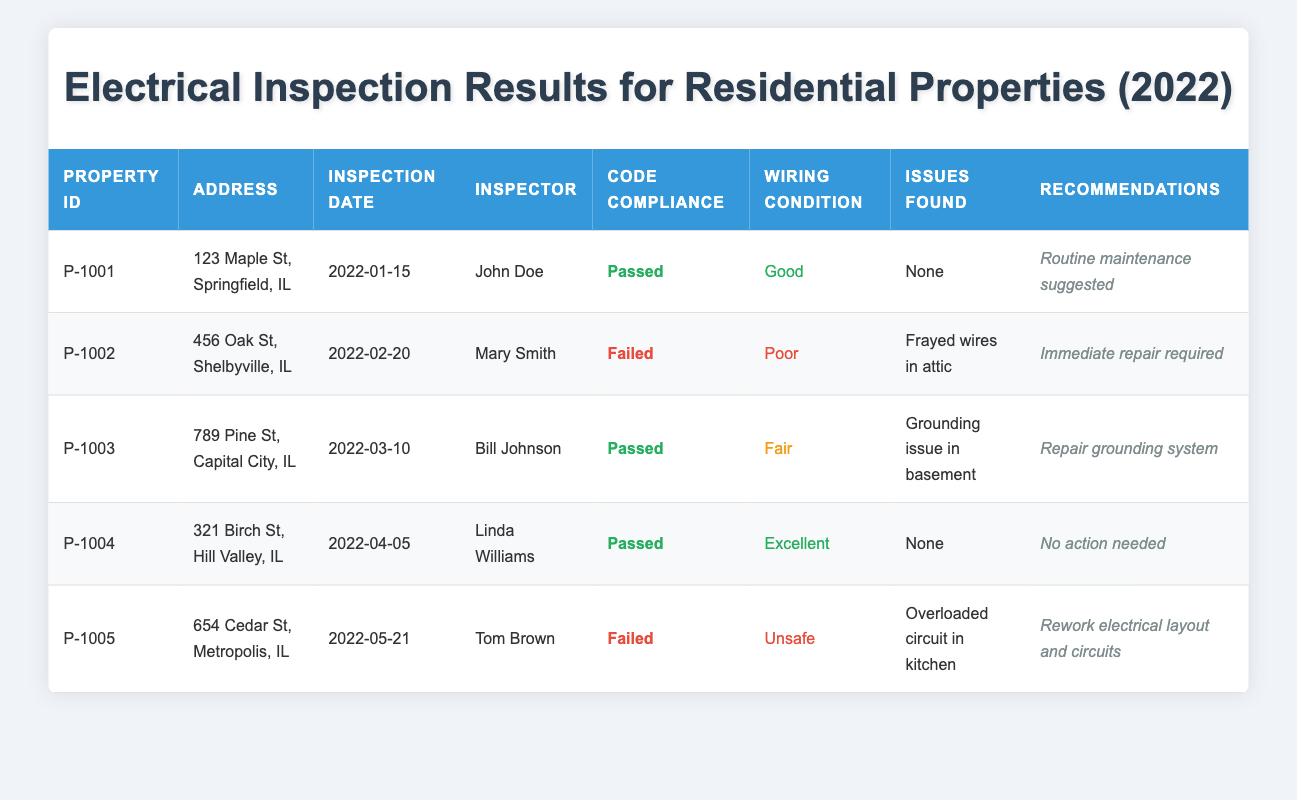What is the address of the property inspected by Mary Smith? In the table, look for the row where the Inspector's name is Mary Smith. The corresponding address in that row is "456 Oak St, Shelbyville, IL."
Answer: 456 Oak St, Shelbyville, IL How many properties passed the electrical code compliance? By reviewing the "Electrical Code Compliance" column, we see that three properties have the status "Passed" (P-1001, P-1003, P-1004). Thus, the count is 3.
Answer: 3 What issues were found in the property at 654 Cedar St, Metropolis, IL? Look at the row for the property with Address "654 Cedar St, Metropolis, IL." The "Issues Found" column for this property states "Overloaded circuit in kitchen."
Answer: Overloaded circuit in kitchen Did any properties require immediate repairs? The "Recommendations" column highlights risk assessments and repair needs. The properties with immediate repair needs are those with "Failed" compliance, notably "Frayed wires in attic" for P-1002 and "Rework electrical layout and circuits" for P-1005. Therefore, yes, immediate repairs are required for both.
Answer: Yes What percentage of properties had unsafe wiring conditions? There are 5 total properties; out of these, 1 property (P-1005) is identified with "Unsafe" wiring conditions. The percentage is calculated as (1/5) * 100 = 20%.
Answer: 20% Which property had the best wiring condition? In the "Wiring Condition" column, the highest rating is "Excellent." This applies to the property with ID P-1004, located at "321 Birch St, Hill Valley, IL."
Answer: 321 Birch St, Hill Valley, IL What are the recommendations for the property that failed inspection due to poor wiring? The inspections show that the property with ID P-1002 has "Immediate repair required" as its recommendation due to "Frayed wires in attic."
Answer: Immediate repair required How many properties were inspected on or before March 10, 2022? Review each inspection date in the table. The properties inspected on or before March 10, 2022, include P-1001, P-1002, and P-1003. This totals 3 properties.
Answer: 3 Is there any property with no action needed? The property with ID P-1004 lists "No action needed" in the recommendations, indicating that its electrical inspection did not reveal any necessary actions.
Answer: Yes 